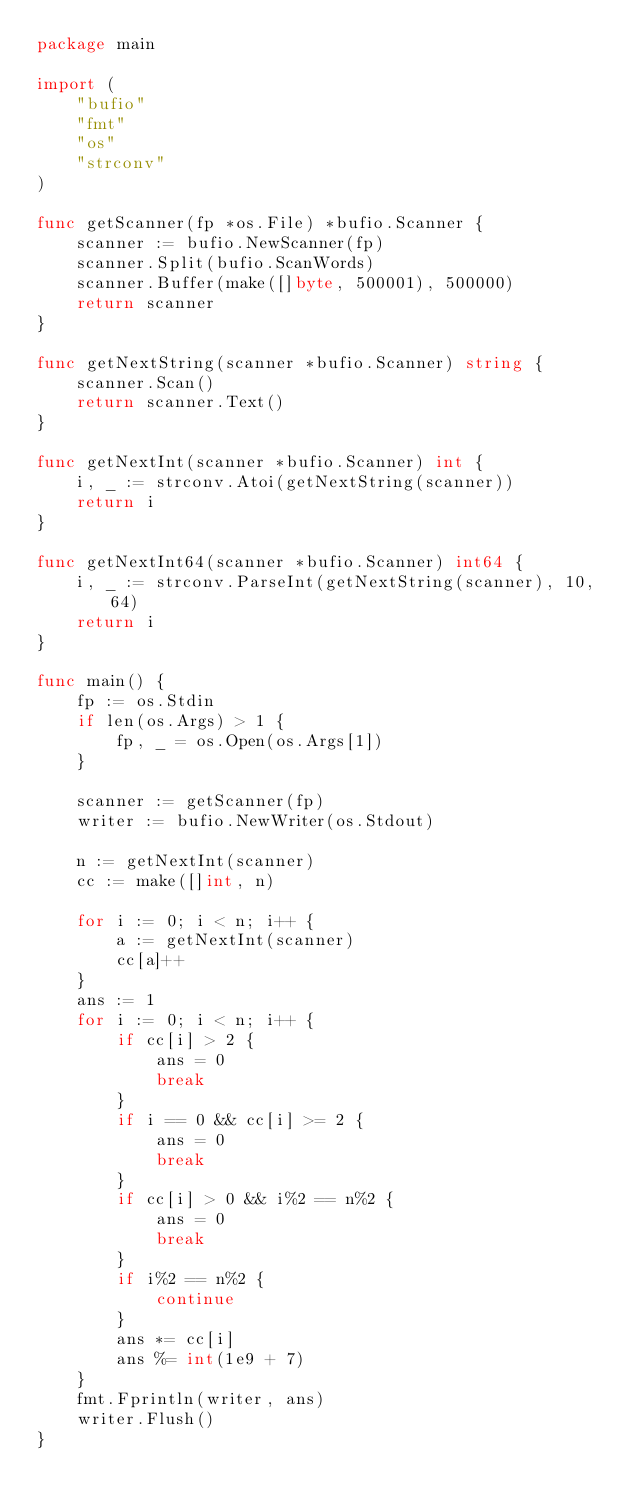Convert code to text. <code><loc_0><loc_0><loc_500><loc_500><_Go_>package main

import (
	"bufio"
	"fmt"
	"os"
	"strconv"
)

func getScanner(fp *os.File) *bufio.Scanner {
	scanner := bufio.NewScanner(fp)
	scanner.Split(bufio.ScanWords)
	scanner.Buffer(make([]byte, 500001), 500000)
	return scanner
}

func getNextString(scanner *bufio.Scanner) string {
	scanner.Scan()
	return scanner.Text()
}

func getNextInt(scanner *bufio.Scanner) int {
	i, _ := strconv.Atoi(getNextString(scanner))
	return i
}

func getNextInt64(scanner *bufio.Scanner) int64 {
	i, _ := strconv.ParseInt(getNextString(scanner), 10, 64)
	return i
}

func main() {
	fp := os.Stdin
	if len(os.Args) > 1 {
		fp, _ = os.Open(os.Args[1])
	}

	scanner := getScanner(fp)
	writer := bufio.NewWriter(os.Stdout)

	n := getNextInt(scanner)
	cc := make([]int, n)

	for i := 0; i < n; i++ {
		a := getNextInt(scanner)
		cc[a]++
	}
	ans := 1
	for i := 0; i < n; i++ {
		if cc[i] > 2 {
			ans = 0
			break
		}
		if i == 0 && cc[i] >= 2 {
			ans = 0
			break
		}
		if cc[i] > 0 && i%2 == n%2 {
			ans = 0
			break
		}
		if i%2 == n%2 {
			continue
		}
		ans *= cc[i]
		ans %= int(1e9 + 7)
	}
	fmt.Fprintln(writer, ans)
	writer.Flush()
}
</code> 